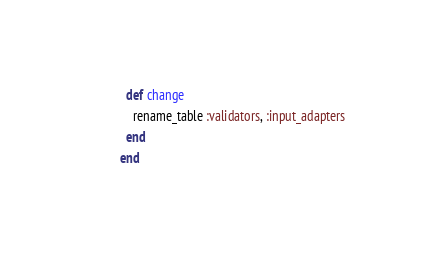<code> <loc_0><loc_0><loc_500><loc_500><_Ruby_>  def change
    rename_table :validators, :input_adapters
  end
end
</code> 